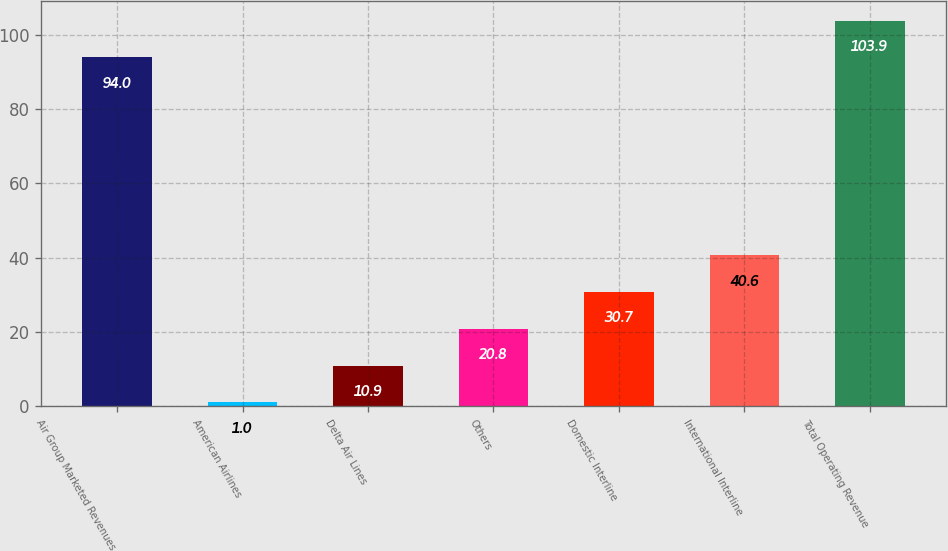<chart> <loc_0><loc_0><loc_500><loc_500><bar_chart><fcel>Air Group Marketed Revenues<fcel>American Airlines<fcel>Delta Air Lines<fcel>Others<fcel>Domestic Interline<fcel>International Interline<fcel>Total Operating Revenue<nl><fcel>94<fcel>1<fcel>10.9<fcel>20.8<fcel>30.7<fcel>40.6<fcel>103.9<nl></chart> 